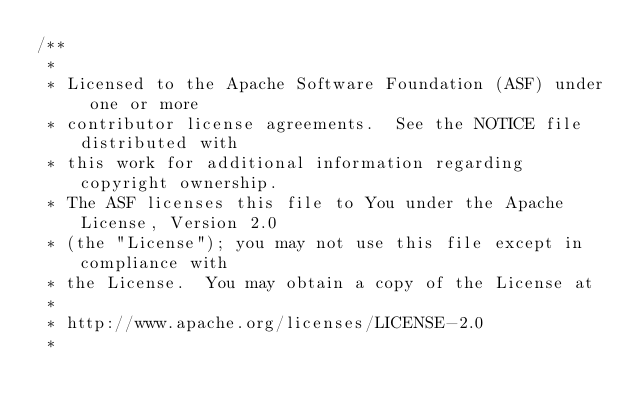<code> <loc_0><loc_0><loc_500><loc_500><_Java_>/**
 *
 * Licensed to the Apache Software Foundation (ASF) under one or more
 * contributor license agreements.  See the NOTICE file distributed with
 * this work for additional information regarding copyright ownership.
 * The ASF licenses this file to You under the Apache License, Version 2.0
 * (the "License"); you may not use this file except in compliance with
 * the License.  You may obtain a copy of the License at
 *
 * http://www.apache.org/licenses/LICENSE-2.0
 *</code> 